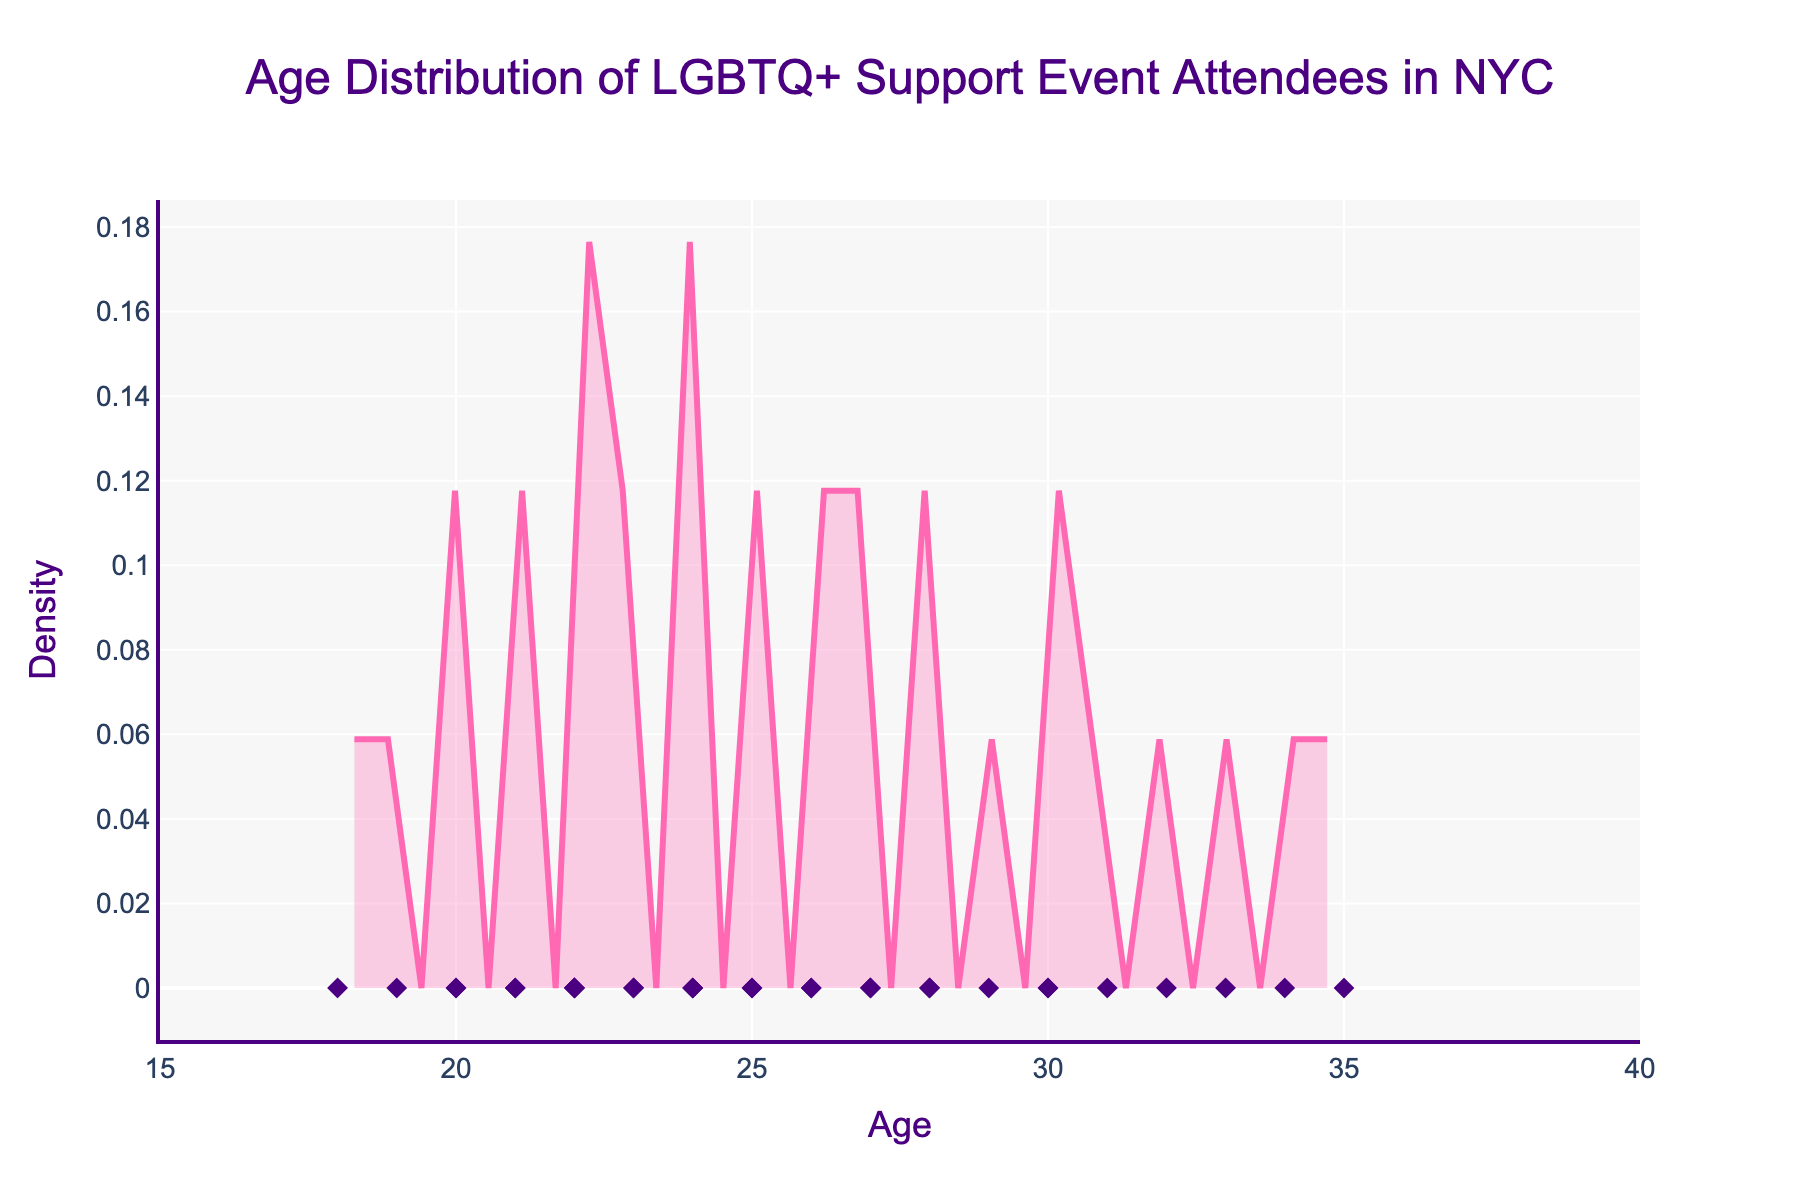What is the title of the figure? The title of the figure is found at the top and is an essential element that describes what the plot is about. In this case, the title clearly states the focus of the plot.
Answer: Age Distribution of LGBTQ+ Support Event Attendees in NYC What are the x-axis and y-axis titles in the figure? The x-axis and y-axis titles are labeled, providing information about what each axis represents. The x-axis represents the age of attendees, and the y-axis represents the density.
Answer: Age (x-axis) and Density (y-axis) What color are the individual data points? The individual data points are represented by a specific color and symbol, making them easily distinguishable on the plot. They are marked by a dark purple diamond symbol.
Answer: Dark purple Between what ages are most attendees concentrated? By looking at the density curve's peaks, we can identify the age range where the density is the highest, indicating the concentration of attendees.
Answer: Between 20 and 26 years old How many data points are represented in the figure? The data points on the figure are indicated by individual markers. Counting these markers gives the total number of attendees represented. There are 30 attendees, one for each age listed in the data.
Answer: 30 What is the approximate age of the oldest attendee? Observing the farthest right data point on the x-axis shows the oldest age among the attendees.
Answer: 35 What is the approximate age of the youngest attendee? Observing the farthest left data point on the x-axis shows the youngest age among the attendees.
Answer: 18 What is the range of ages for attendees with the highest density? The highest density is where the curve reaches its peak, indicating the range where attendees are most concentrated. This can be seen in the density plot between ages 20 and 25.
Answer: 20 to 25 years old Are there any age gaps with no attendees within the plotted age range? By examining the plot, we can see if there are any segments of the x-axis where no individual data points are plotted, indicating age gaps. No significant gaps are present in the figure.
Answer: No How does the density change as age increases from 18 to 35? Examining the density curve from left to right, we can see the density increase to a peak and then gradually decrease as age progresses toward 35. This shows a common age distribution pattern.
Answer: Increases to a peak then decreases 